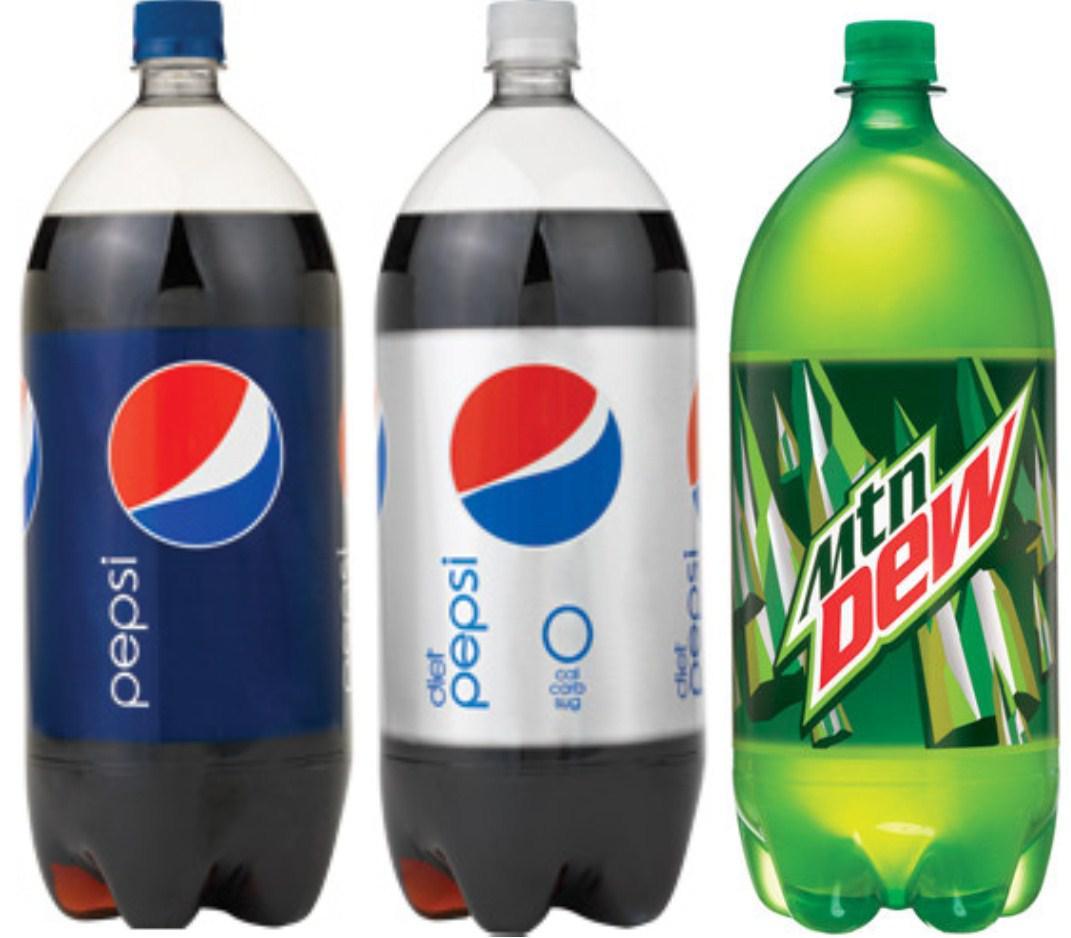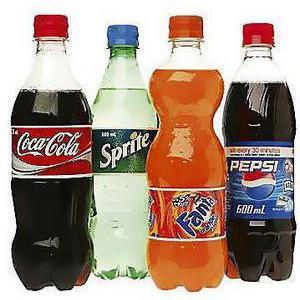The first image is the image on the left, the second image is the image on the right. Given the left and right images, does the statement "There are at least seven bottles in total." hold true? Answer yes or no. Yes. 